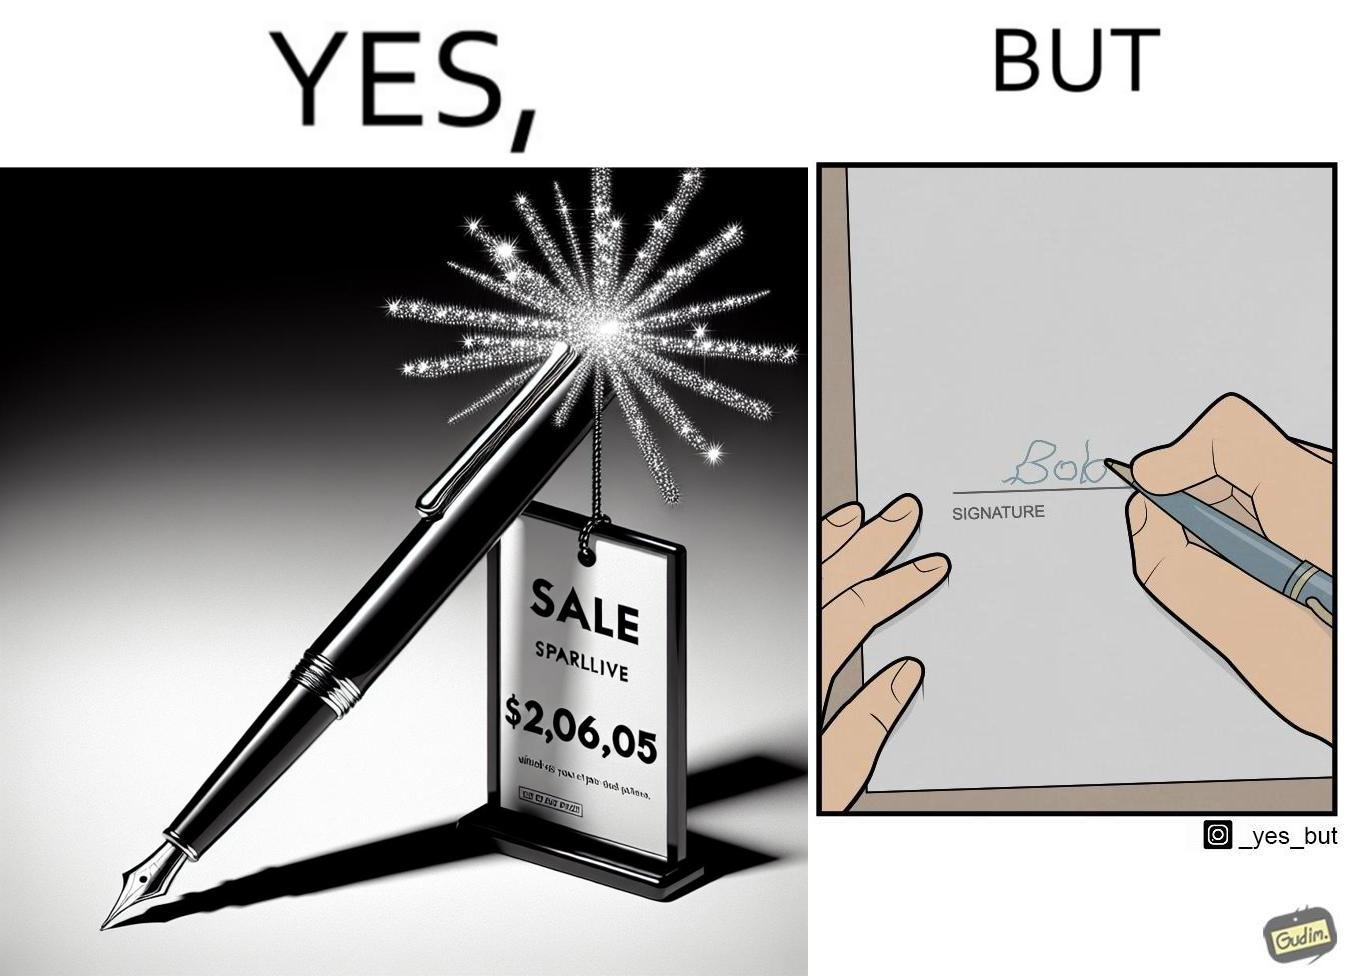What is shown in this image? The image is ironic, because it conveys the message that even with the costliest of pens people handwriting remains the same 